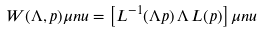Convert formula to latex. <formula><loc_0><loc_0><loc_500><loc_500>W ( \Lambda , p ) \mu n u = \left [ L ^ { - 1 } ( \Lambda p ) \, \Lambda \, L ( p ) \right ] \mu n u</formula> 